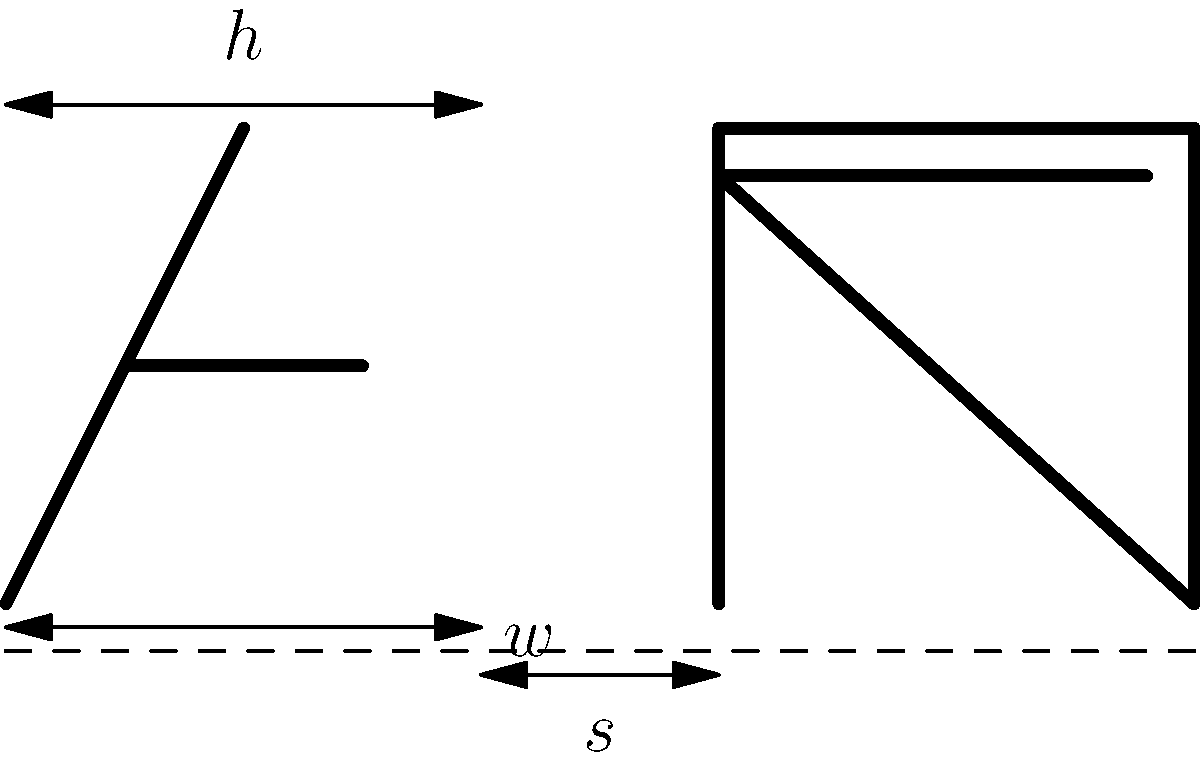In traditional Hebrew calligraphy, the proportions and spacing of letters are crucial for aesthetic and legibility reasons. Given the diagram showing the Hebrew letters Alef (א) and Bet (ב), what is the ideal ratio of the letter height ($h$) to the letter width ($w$) for most Hebrew letters, and how does this relate to the spacing ($s$) between letters? To answer this question, we need to consider the traditional rules of Hebrew calligraphy:

1. Letter Proportions:
   - In classical Hebrew calligraphy, most letters are designed to fit within a square.
   - The ideal ratio of height ($h$) to width ($w$) for most Hebrew letters is 1:1.

2. Letter Spacing:
   - The space between letters ($s$) is typically related to the width of the letters.
   - In traditional calligraphy, the spacing is usually about 1/3 of the letter width.

3. Calculation:
   - If we denote the letter width as $w$, then:
     * Letter height: $h = w$
     * Letter spacing: $s = \frac{1}{3}w$

4. Ratio Expression:
   - We can express the relationship between height, width, and spacing as:
     $h : w : s = 1 : 1 : \frac{1}{3}$

5. Importance:
   - This ratio ensures a balanced and harmonious appearance of the text.
   - It allows for clear distinction between letters while maintaining visual flow.

6. Exceptions:
   - Some letters (like final forms) may deviate from this ratio for specific reasons.
   - Artistic styles might slightly modify these proportions while maintaining readability.

Therefore, the ideal ratio of letter height to width is 1:1, and the spacing is typically 1/3 of the letter width, resulting in a proportion of 1:1:1/3 for height:width:spacing.
Answer: $h : w : s = 1 : 1 : \frac{1}{3}$ 